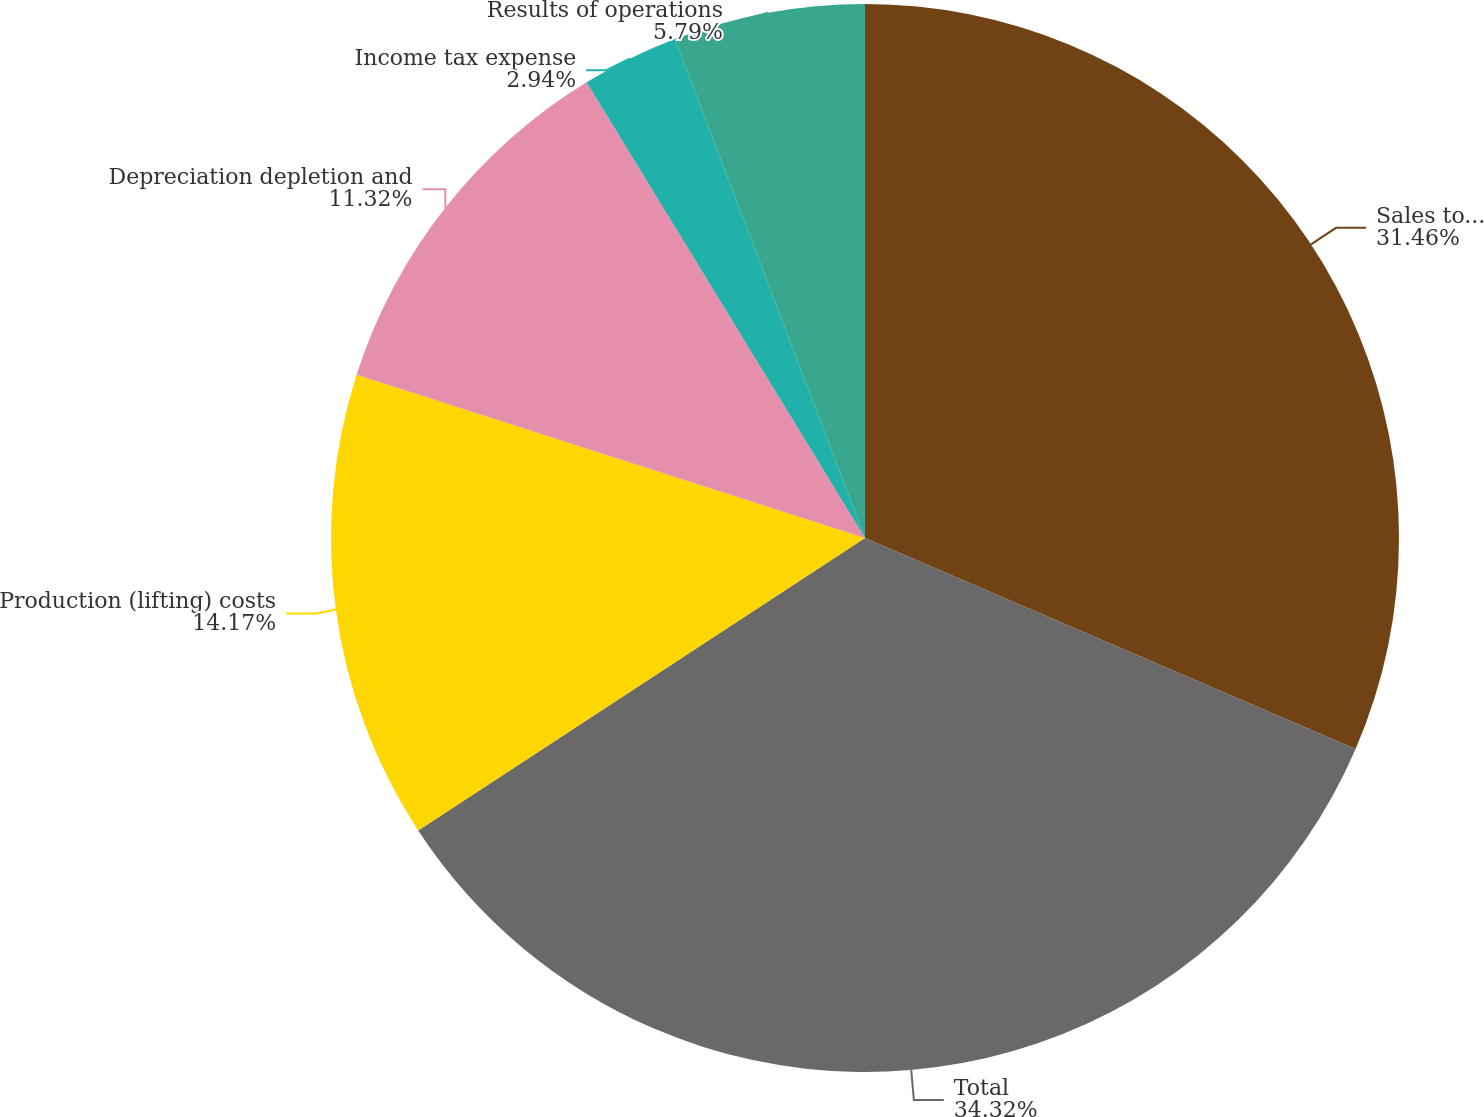Convert chart. <chart><loc_0><loc_0><loc_500><loc_500><pie_chart><fcel>Sales to nonaffiliated<fcel>Total<fcel>Production (lifting) costs<fcel>Depreciation depletion and<fcel>Income tax expense<fcel>Results of operations<nl><fcel>31.46%<fcel>34.31%<fcel>14.17%<fcel>11.32%<fcel>2.94%<fcel>5.79%<nl></chart> 